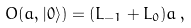<formula> <loc_0><loc_0><loc_500><loc_500>O ( a , | 0 \rangle ) = ( L _ { - 1 } + L _ { 0 } ) a \, ,</formula> 